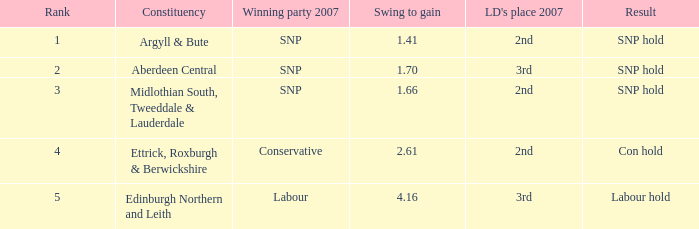What is the minimum position when the electoral district is edinburgh northern and leith, and the swing to achieve is below None. 